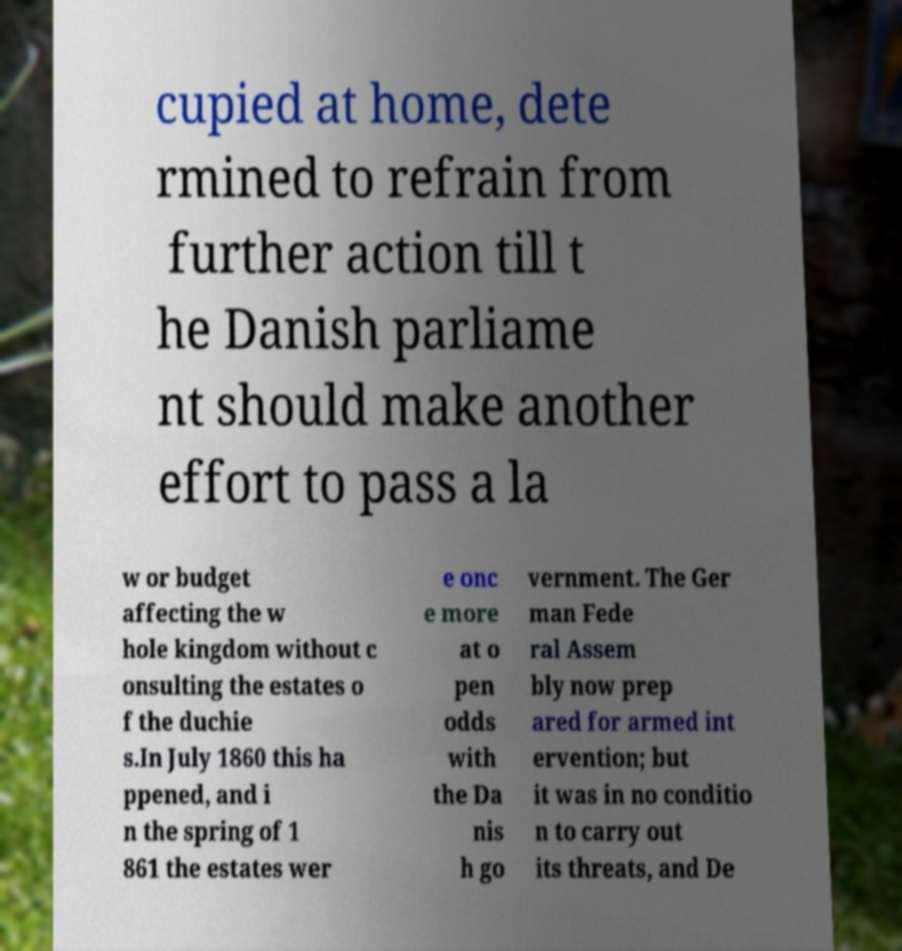Can you accurately transcribe the text from the provided image for me? cupied at home, dete rmined to refrain from further action till t he Danish parliame nt should make another effort to pass a la w or budget affecting the w hole kingdom without c onsulting the estates o f the duchie s.In July 1860 this ha ppened, and i n the spring of 1 861 the estates wer e onc e more at o pen odds with the Da nis h go vernment. The Ger man Fede ral Assem bly now prep ared for armed int ervention; but it was in no conditio n to carry out its threats, and De 